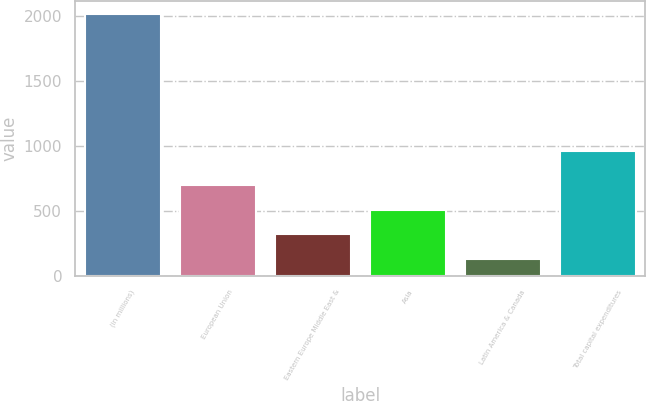<chart> <loc_0><loc_0><loc_500><loc_500><bar_chart><fcel>(in millions)<fcel>European Union<fcel>Eastern Europe Middle East &<fcel>Asia<fcel>Latin America & Canada<fcel>Total capital expenditures<nl><fcel>2015<fcel>695.5<fcel>318.5<fcel>507<fcel>130<fcel>960<nl></chart> 